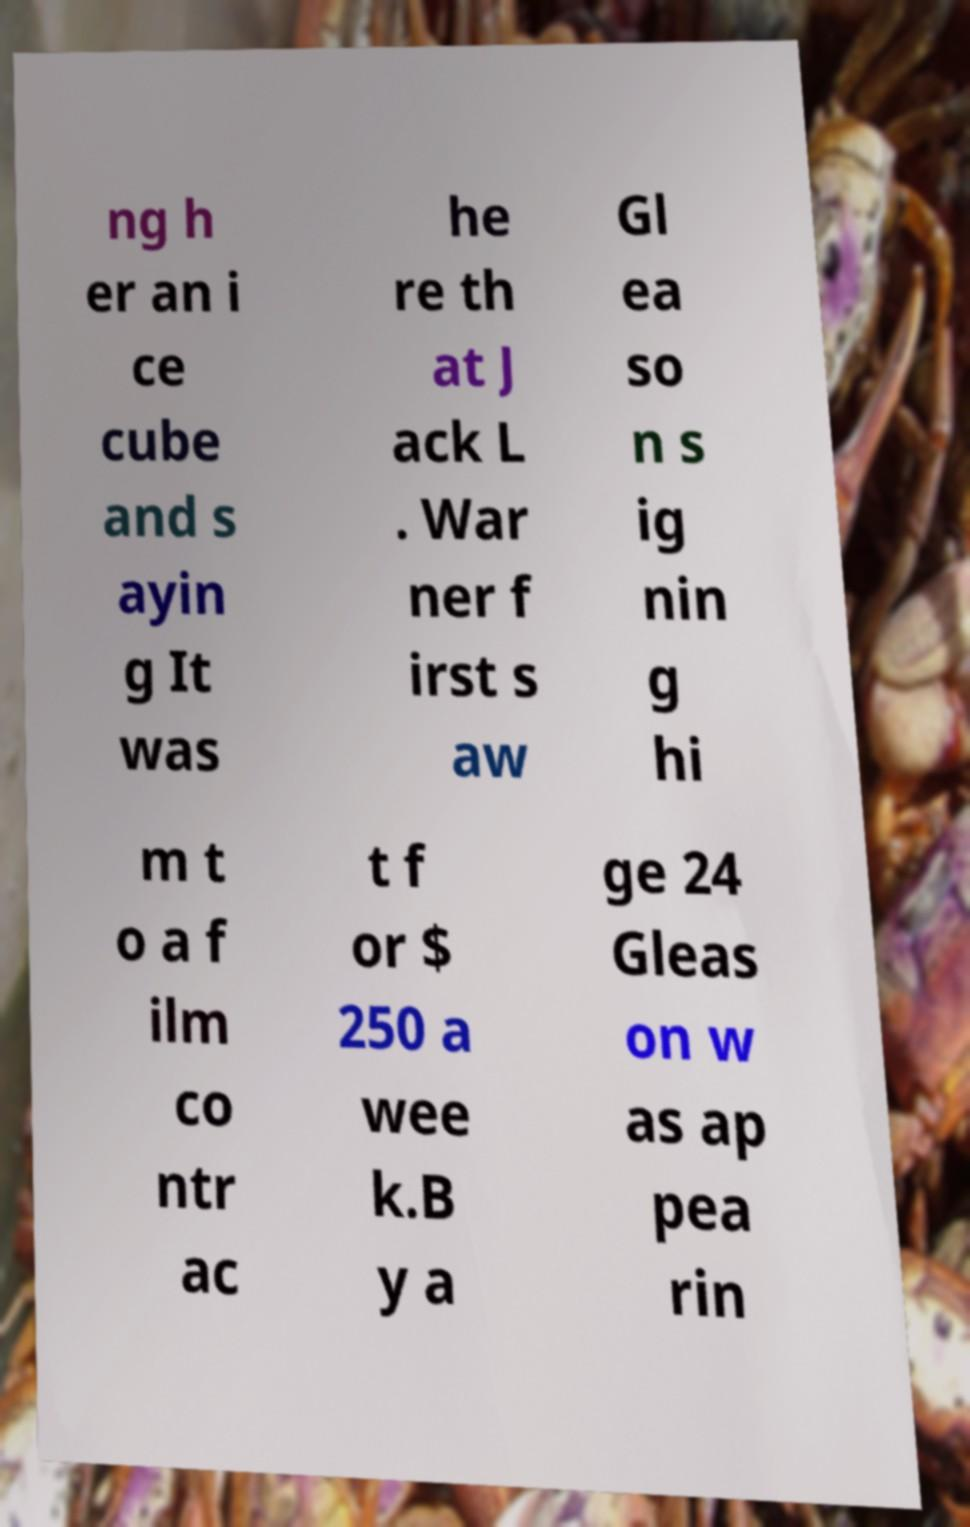What messages or text are displayed in this image? I need them in a readable, typed format. ng h er an i ce cube and s ayin g It was he re th at J ack L . War ner f irst s aw Gl ea so n s ig nin g hi m t o a f ilm co ntr ac t f or $ 250 a wee k.B y a ge 24 Gleas on w as ap pea rin 